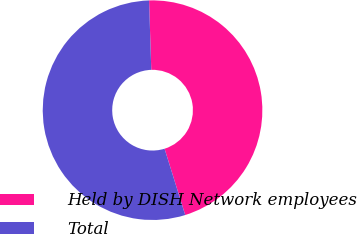Convert chart to OTSL. <chart><loc_0><loc_0><loc_500><loc_500><pie_chart><fcel>Held by DISH Network employees<fcel>Total<nl><fcel>45.7%<fcel>54.3%<nl></chart> 